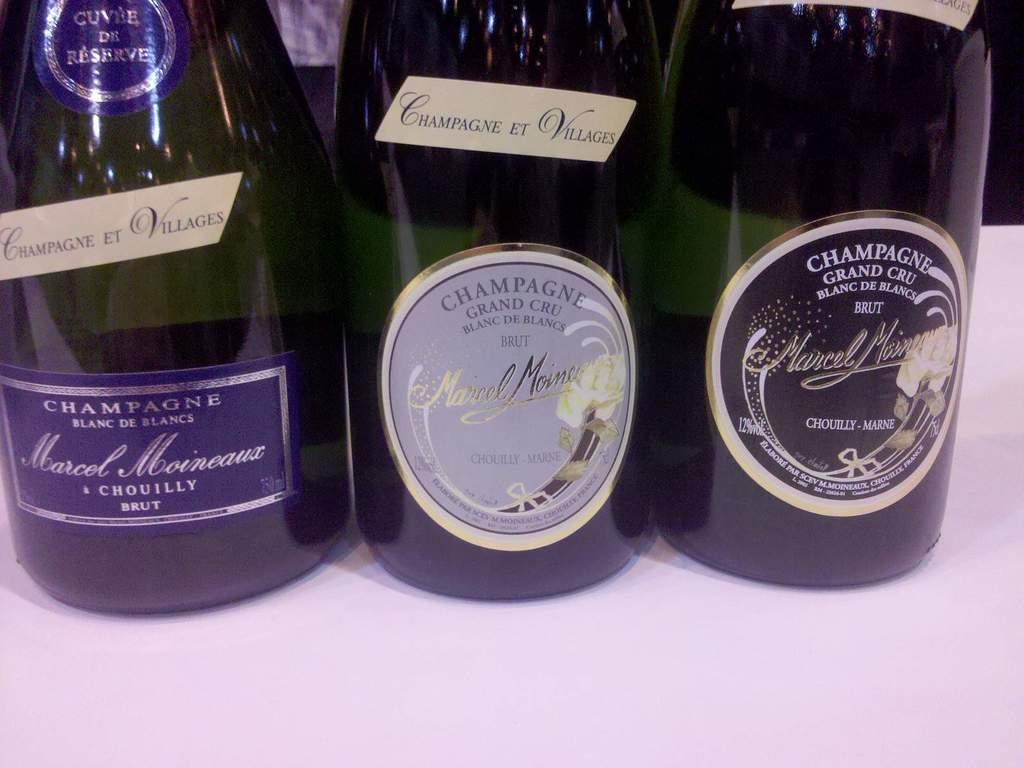<image>
Describe the image concisely. WIne bottles with one that has a label which says "CHAMPAGNE GRAND CRU". 